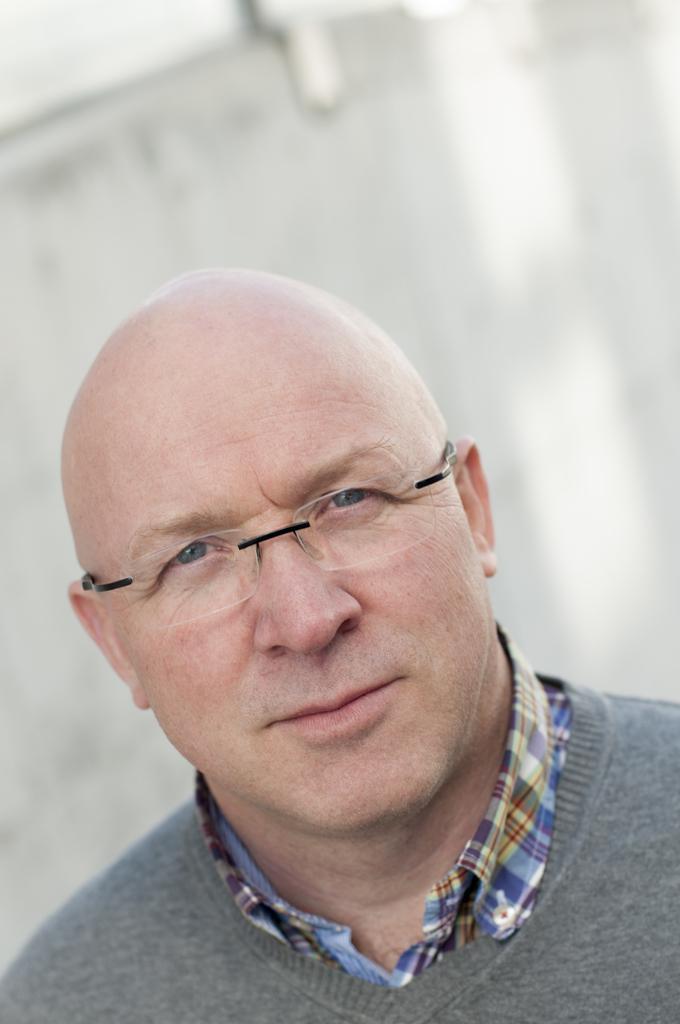Please provide a concise description of this image. In this image I see a man over here who is wearing grey color t-shirt and a colorful shirt and I see that he is also wearing spectacle and I see that it is white in the background. 